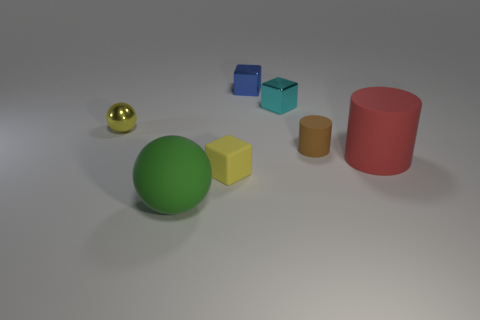There is a ball that is right of the yellow thing behind the tiny brown thing; what color is it?
Your answer should be very brief. Green. Is there another small matte cylinder of the same color as the small rubber cylinder?
Your answer should be compact. No. There is a brown object that is the same size as the cyan metallic thing; what is its shape?
Make the answer very short. Cylinder. How many large rubber things are behind the large thing that is to the left of the blue cube?
Your response must be concise. 1. Do the large ball and the large cylinder have the same color?
Provide a short and direct response. No. What number of other objects are the same material as the big red cylinder?
Give a very brief answer. 3. The small matte object that is in front of the big matte cylinder that is in front of the small metallic ball is what shape?
Give a very brief answer. Cube. There is a yellow thing on the left side of the yellow matte block; what size is it?
Offer a terse response. Small. Is the material of the blue object the same as the red cylinder?
Keep it short and to the point. No. The small yellow object that is made of the same material as the tiny blue thing is what shape?
Provide a succinct answer. Sphere. 